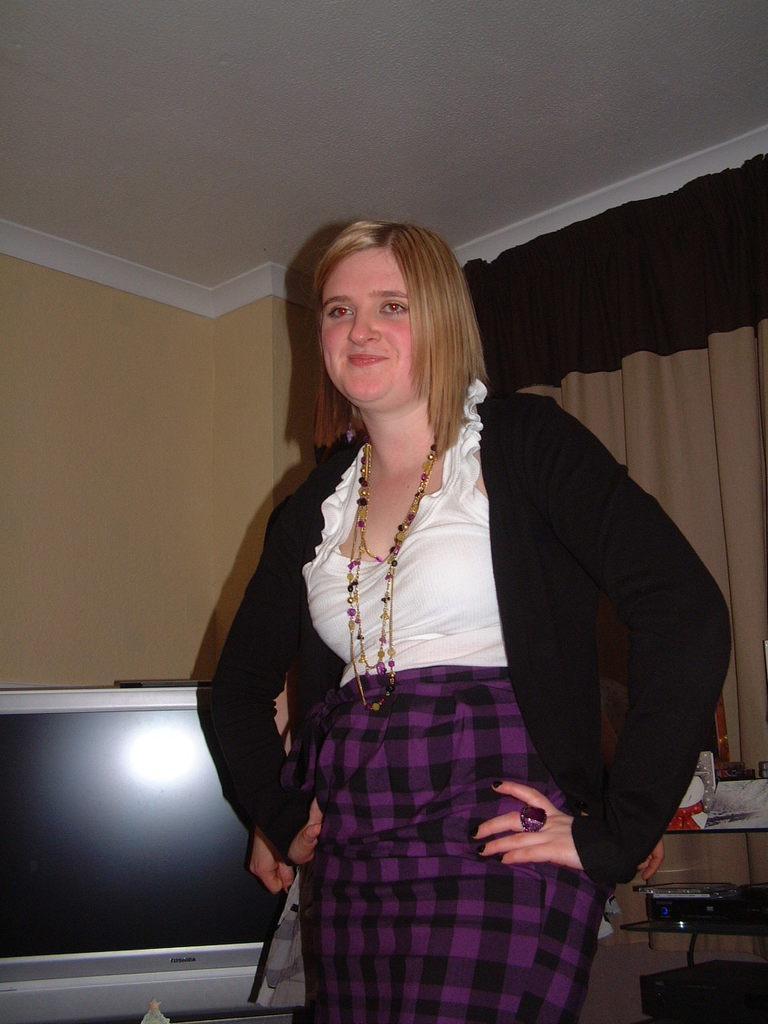Describe this image in one or two sentences. In this picture there is a man who is standing near to the television. On the bottom right corner we can see some books and other objects on the rack. Beside that we can see window cloth. 